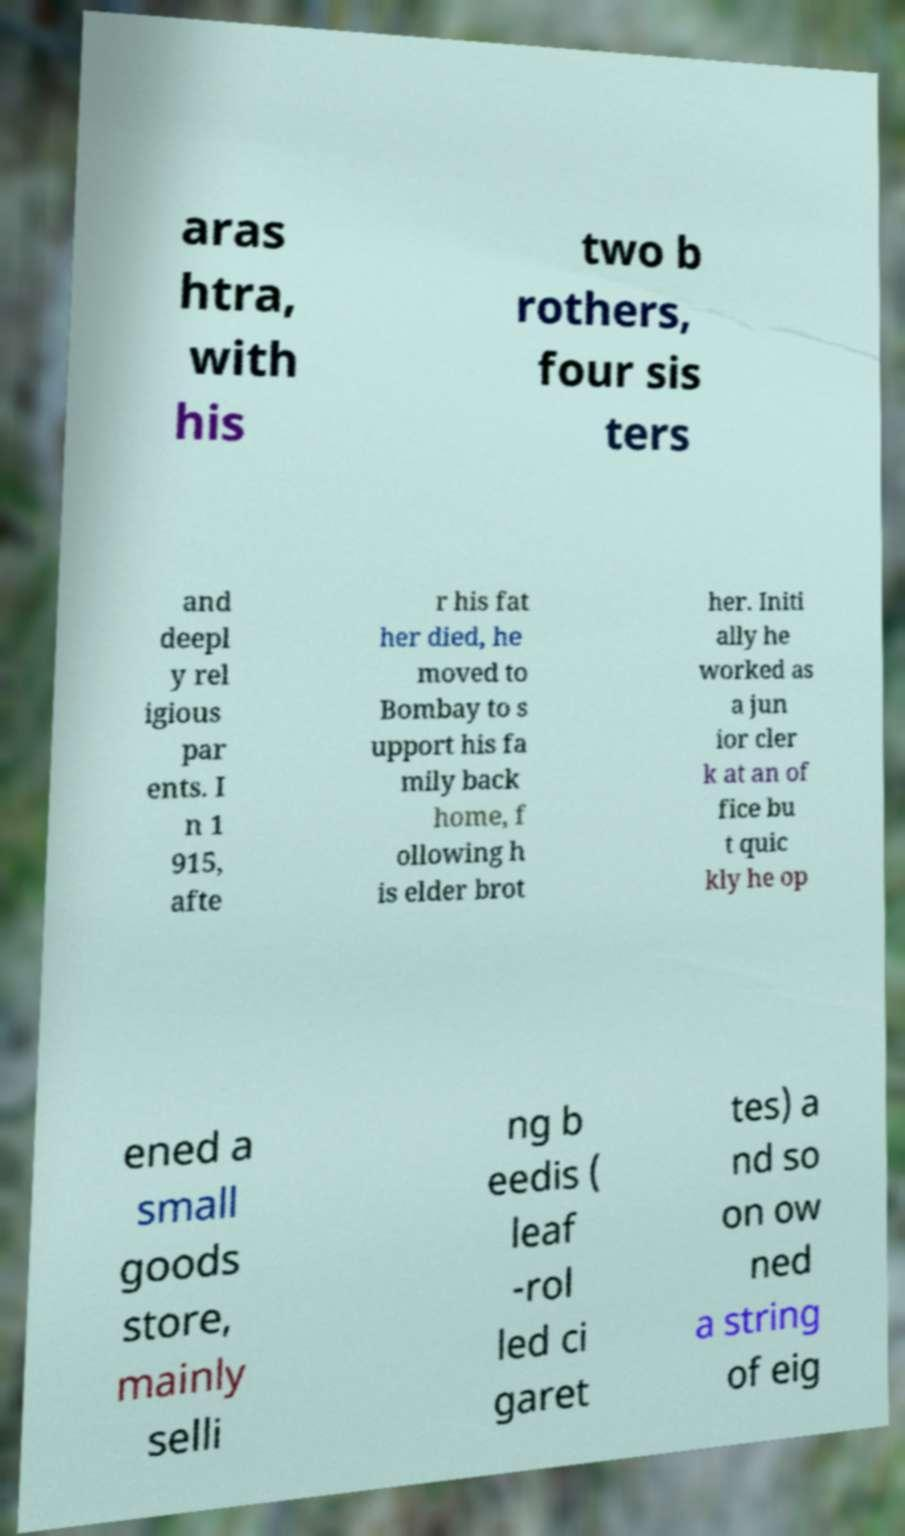For documentation purposes, I need the text within this image transcribed. Could you provide that? aras htra, with his two b rothers, four sis ters and deepl y rel igious par ents. I n 1 915, afte r his fat her died, he moved to Bombay to s upport his fa mily back home, f ollowing h is elder brot her. Initi ally he worked as a jun ior cler k at an of fice bu t quic kly he op ened a small goods store, mainly selli ng b eedis ( leaf -rol led ci garet tes) a nd so on ow ned a string of eig 